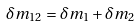Convert formula to latex. <formula><loc_0><loc_0><loc_500><loc_500>\delta m _ { 1 2 } = \delta m _ { 1 } + \delta m _ { 2 }</formula> 